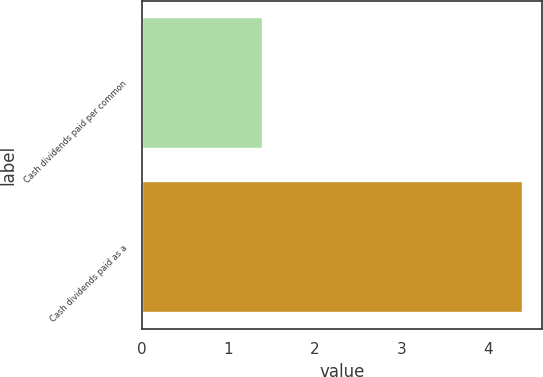Convert chart. <chart><loc_0><loc_0><loc_500><loc_500><bar_chart><fcel>Cash dividends paid per common<fcel>Cash dividends paid as a<nl><fcel>1.4<fcel>4.4<nl></chart> 